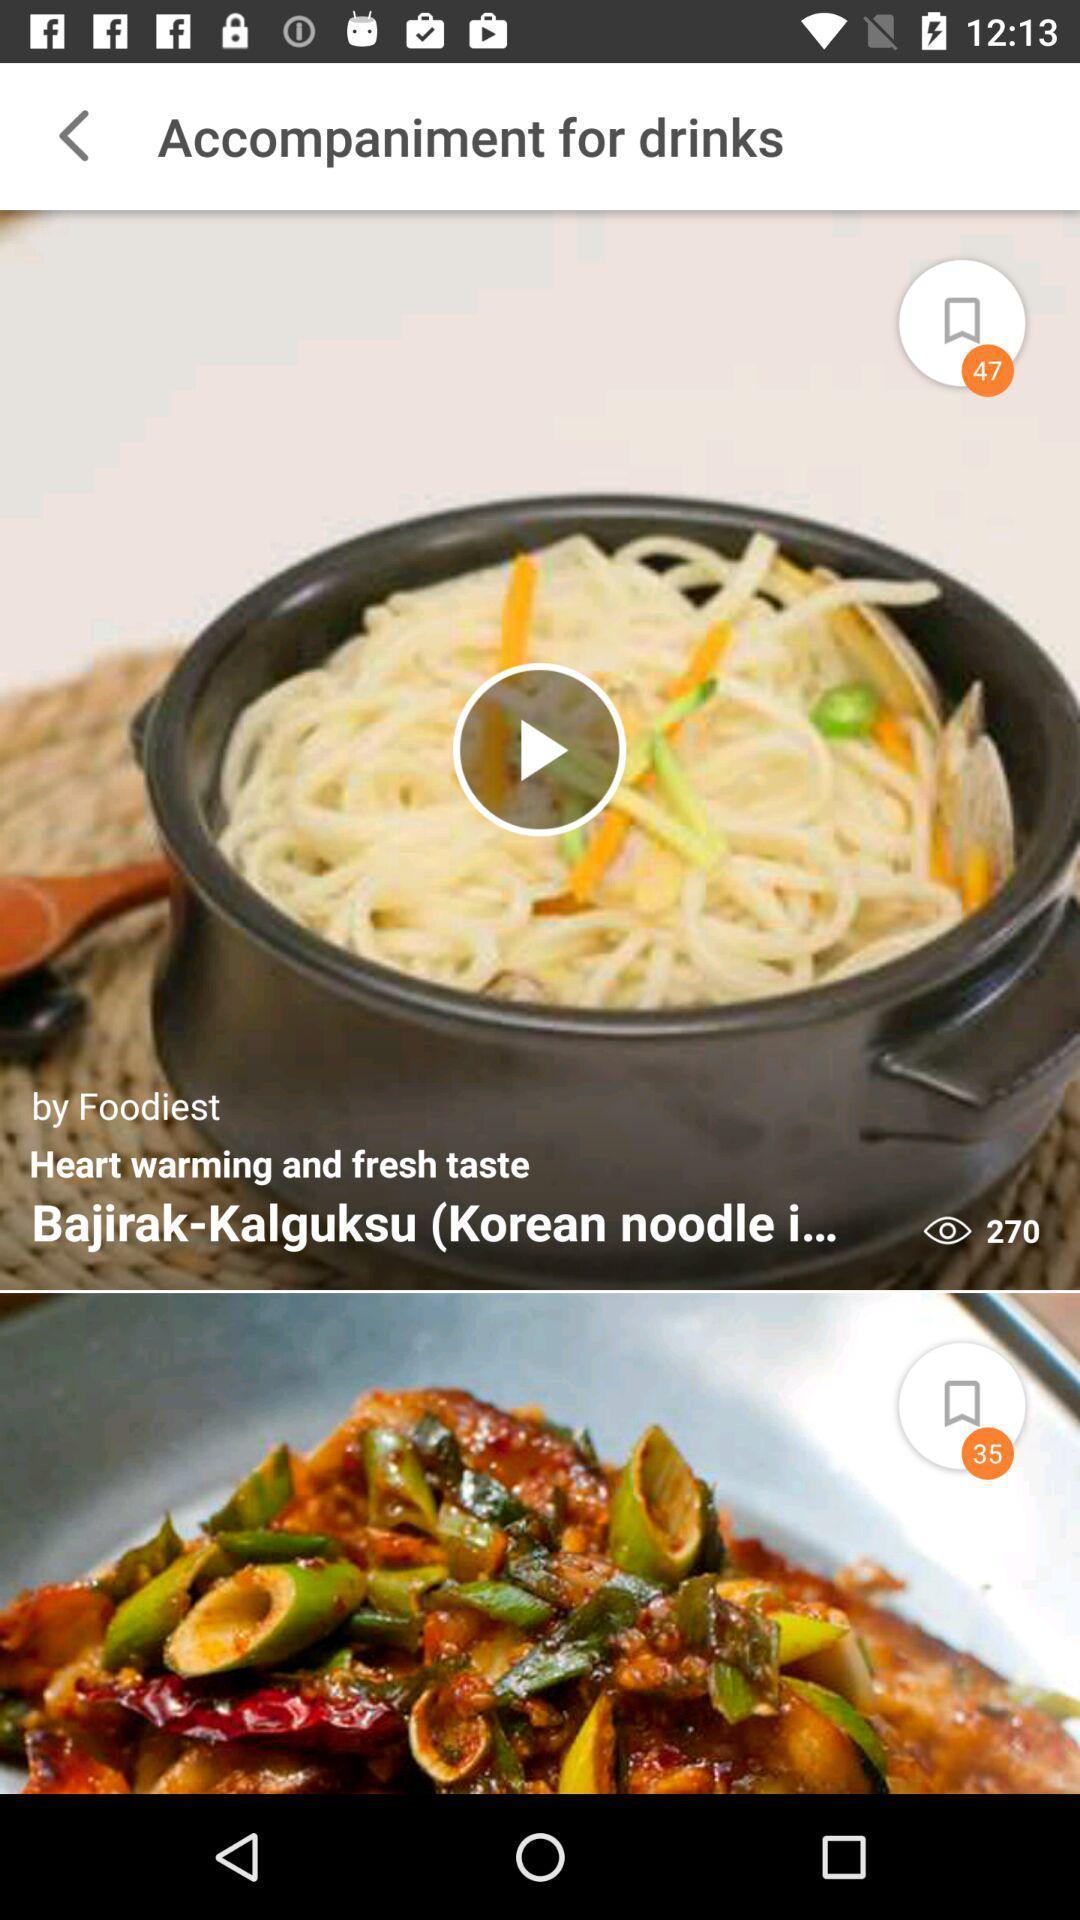Summarize the information in this screenshot. Page showing recipes on a food app. 